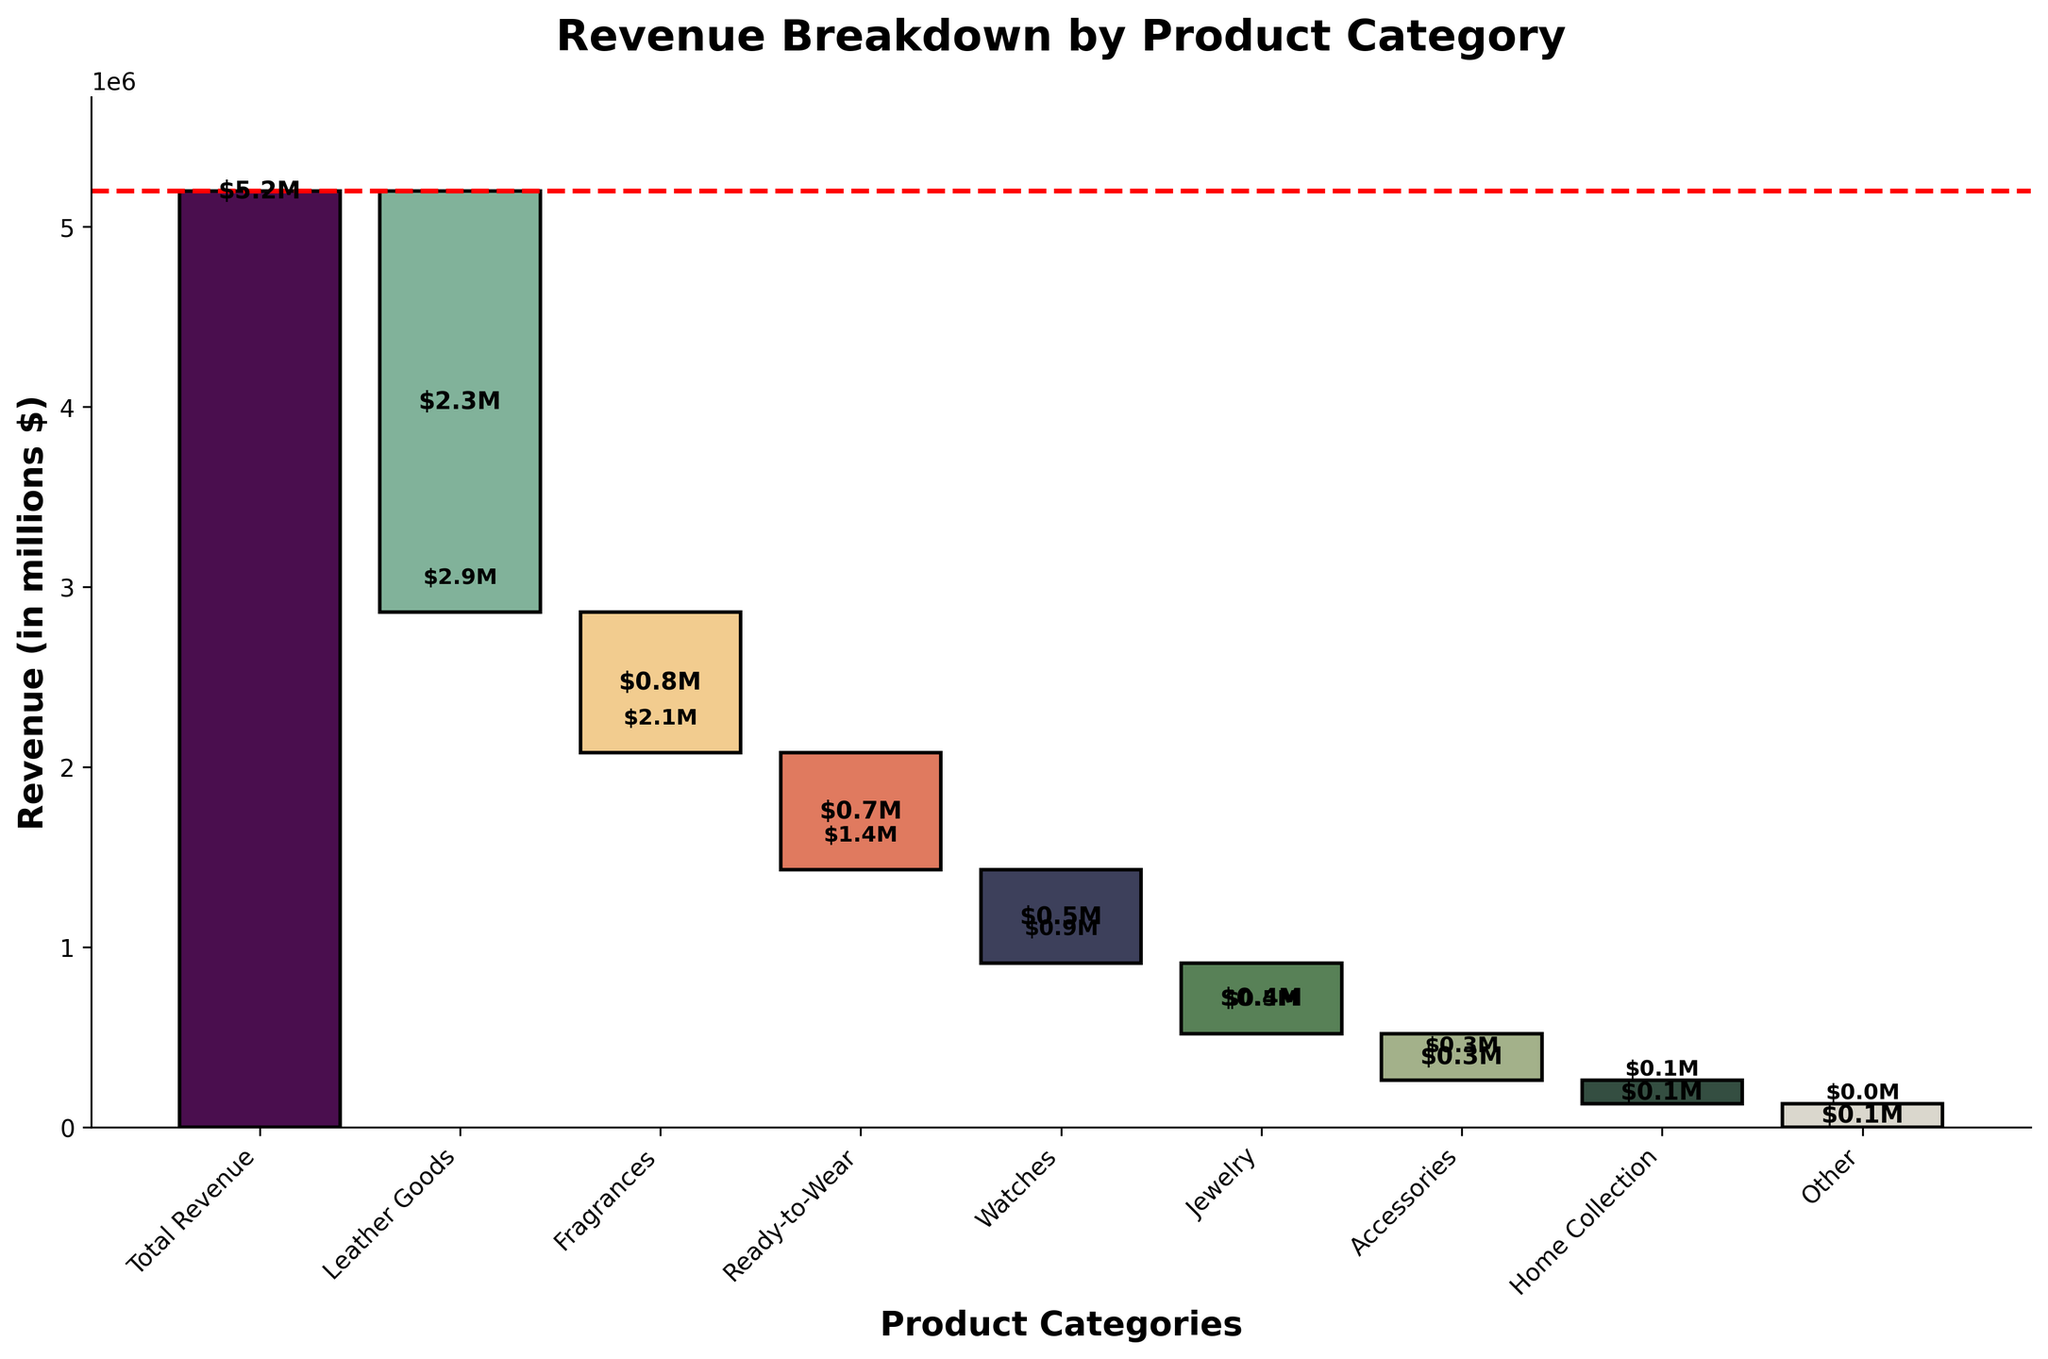What is the title of the chart? The title of the chart is displayed at the top in bold and larger font size as "Revenue Breakdown by Product Category".
Answer: Revenue Breakdown by Product Category What is the total revenue represented in the chart? The total revenue is indicated by the first bar on the Waterfall Chart with the label "$5.2M".
Answer: $5.2M How much revenue did Leather Goods contribute? The bar associated with Leather Goods shows a decline in the cumulative revenue, and it is labeled as "-$2.34M".
Answer: -$2.34M Which product category contributed the least amount of revenue? By examining each bar label, we can see that Home Collection and Other categories each have the lowest contribution of "-$0.13M".
Answer: Home Collection and Other What's the total revenue after subtracting Leather Goods and Fragrances? First subtract Leather Goods revenue of $2.34M from the total of $5.2M, resulting in $2.86M. Then, subtract Fragrances revenue of $0.78M from $2.86M, giving the final result.
Answer: $2.08M Which category has the second highest negative impact on total revenue? The revenues are shown in decreasing negative order; the second bar is Fragrances which indicates a negative impact of "-$0.78M".
Answer: Fragrances Are there any product categories that contributed positively to the revenue? All categories depicted in the chart have negative values indicating deductions from the total revenue.
Answer: No What is the cumulative revenue after subtracting the contributions from Leather Goods, Fragrances, and Ready-to-Wear categories? Starting from the total of $5.2M, first subtract Leather Goods ($2.34M), resulting in $2.86M. Next, subtract Fragrances ($0.78M) from $2.86M, resulting in $2.08M. Subtract Ready-to-Wear ($0.65M) from $2.08M, resulting in $1.43M.
Answer: $1.43M Is the total revenue line aligned with the total revenue of the product categories? A red dashed horizontal line represents the total revenue and aligns with the bar for Total Revenue, verifying its accuracy.
Answer: Yes 